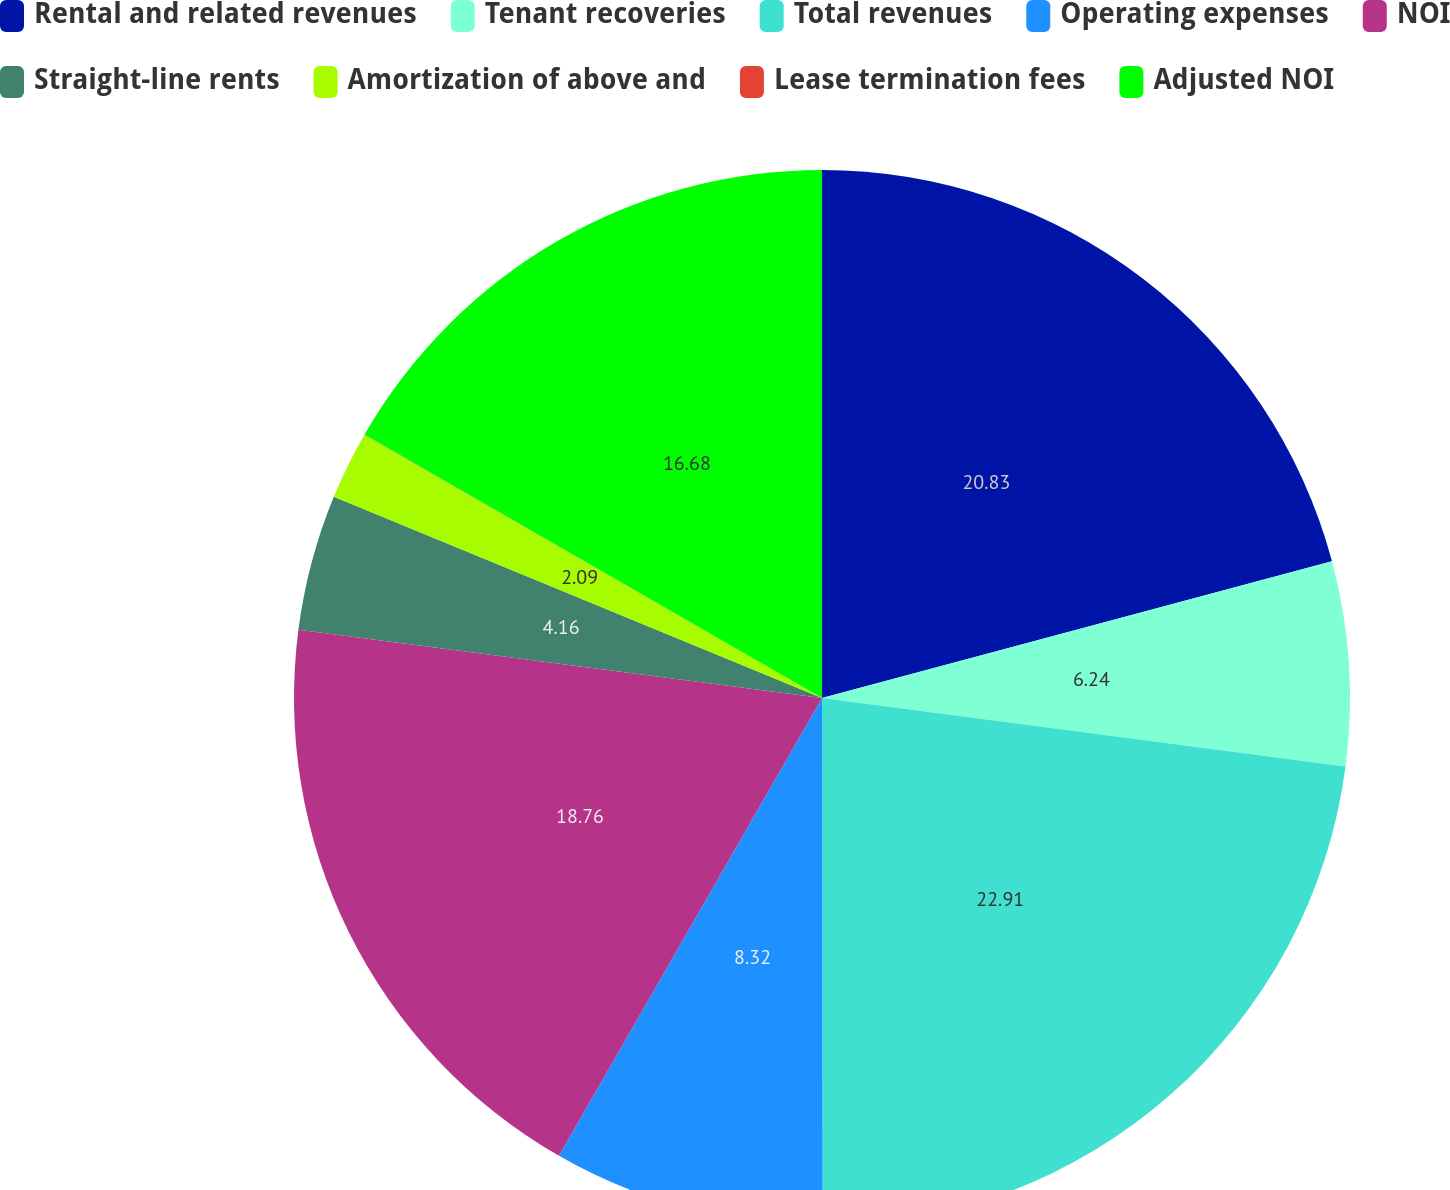Convert chart to OTSL. <chart><loc_0><loc_0><loc_500><loc_500><pie_chart><fcel>Rental and related revenues<fcel>Tenant recoveries<fcel>Total revenues<fcel>Operating expenses<fcel>NOI<fcel>Straight-line rents<fcel>Amortization of above and<fcel>Lease termination fees<fcel>Adjusted NOI<nl><fcel>20.83%<fcel>6.24%<fcel>22.91%<fcel>8.32%<fcel>18.76%<fcel>4.16%<fcel>2.09%<fcel>0.01%<fcel>16.68%<nl></chart> 